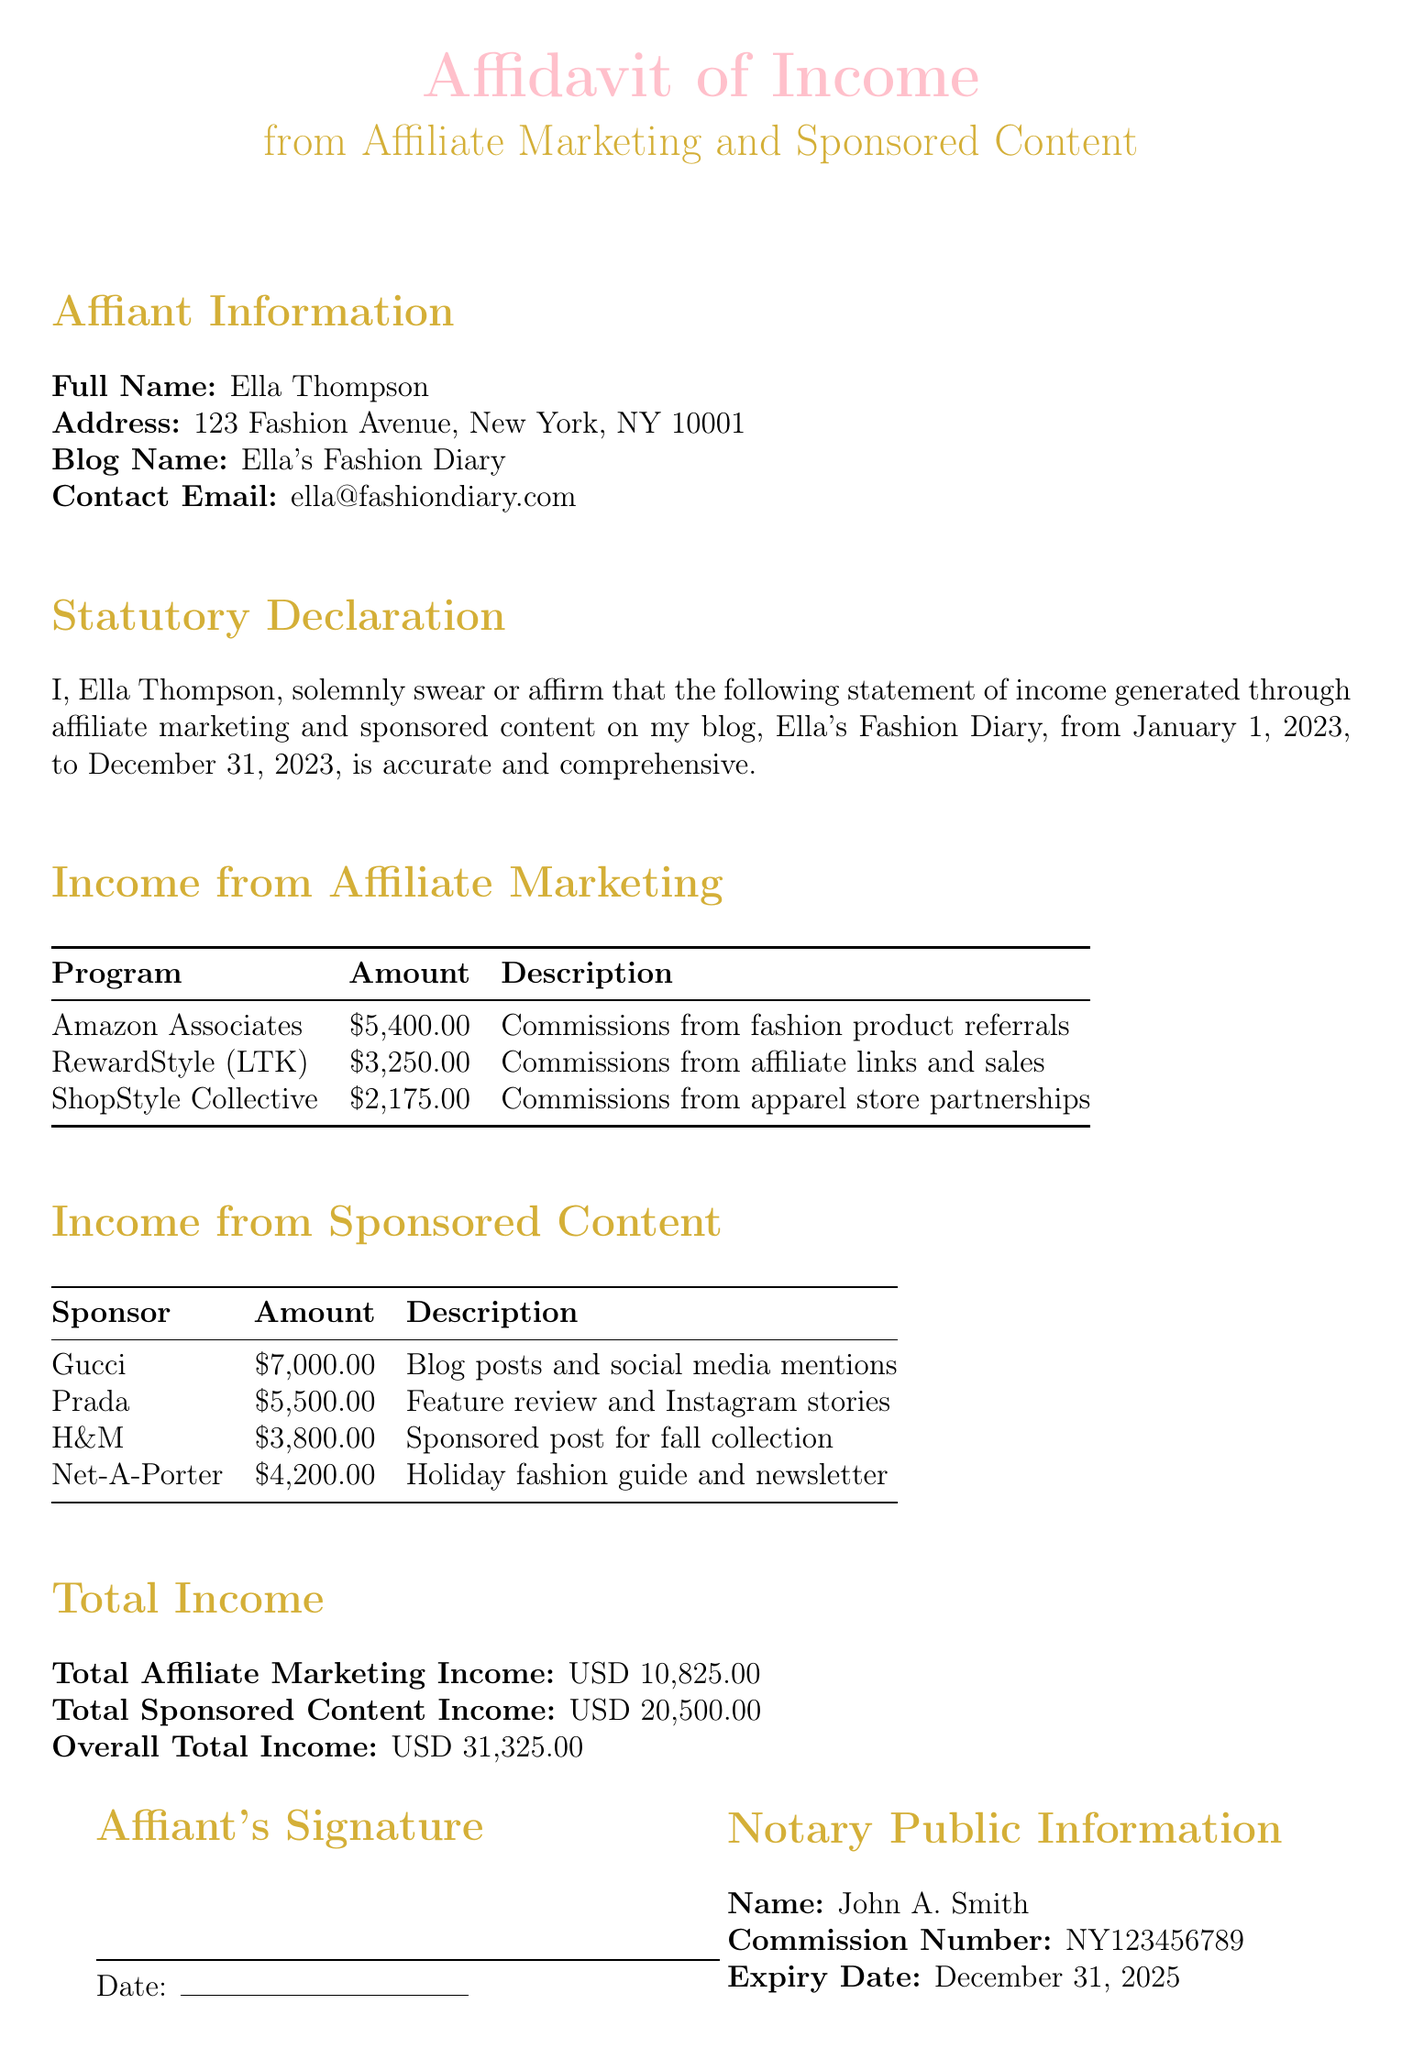What is the full name of the affiant? The affiant's full name is mentioned in the Affiant Information section.
Answer: Ella Thompson What is the total income from sponsored content? The total income from sponsored content is provided in the Total Income section of the document.
Answer: USD 20,500.00 Which affiliate marketing program generated the most income? The program with the highest income is indicated in the Income from Affiliate Marketing section of the document.
Answer: Amazon Associates What is the address of the affiant? The affiant's address can be found in the Affiant Information section.
Answer: 123 Fashion Avenue, New York, NY 10001 Who is the notary public? The name of the notary public is listed in the Notary Public Information section.
Answer: John A. Smith What was the total affiliate marketing income? The total affiliate marketing income is specified in the Total Income section.
Answer: USD 10,825.00 When does the notary public's commission expire? The expiry date of the notary public’s commission is indicated in the Notary Public Information section.
Answer: December 31, 2025 What is the amount received from Gucci? The amount received from Gucci is provided in the Income from Sponsored Content section.
Answer: USD 7,000.00 What is the blog name? The blog name is detailed in the Affiant Information section.
Answer: Ella's Fashion Diary 